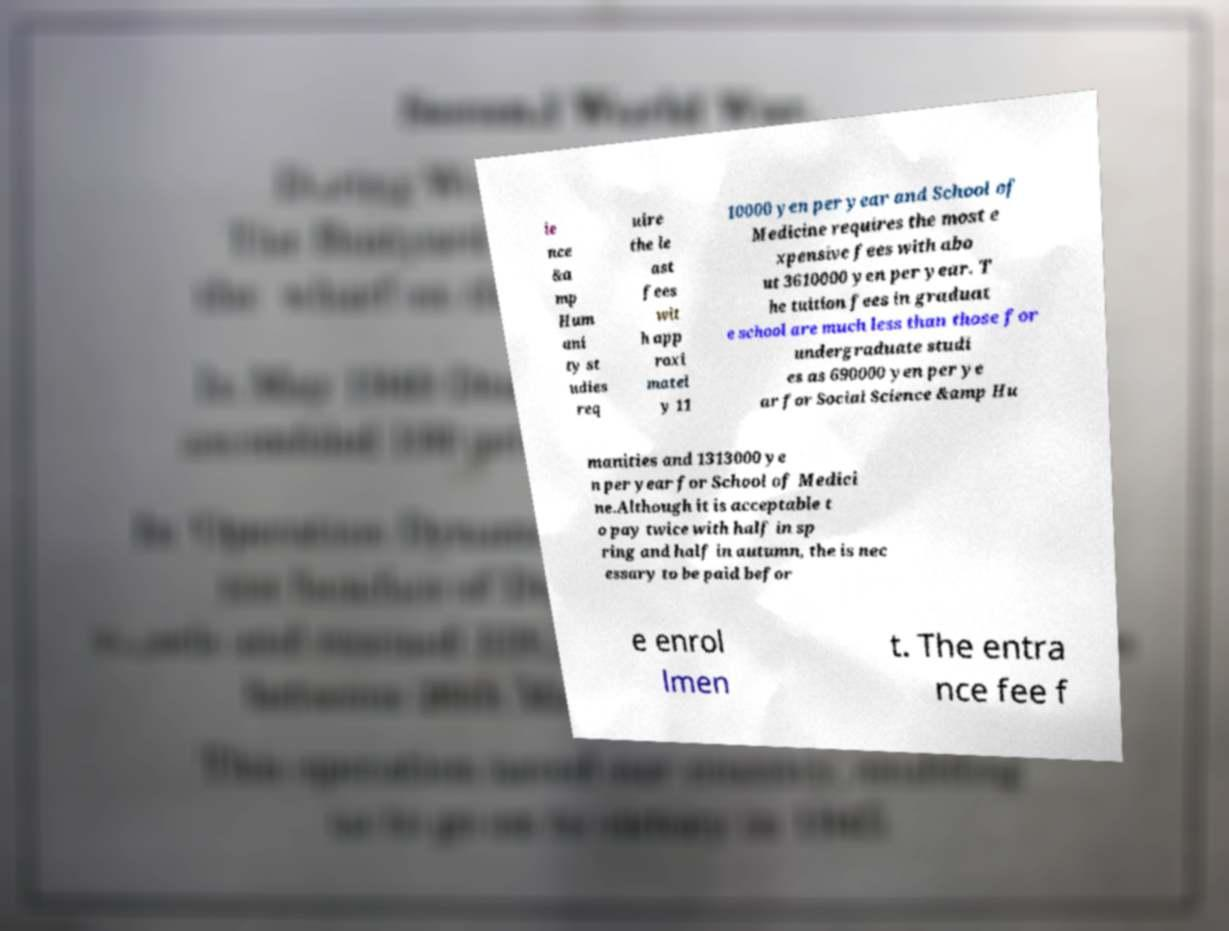Could you extract and type out the text from this image? ie nce &a mp Hum ani ty st udies req uire the le ast fees wit h app roxi matel y 11 10000 yen per year and School of Medicine requires the most e xpensive fees with abo ut 3610000 yen per year. T he tuition fees in graduat e school are much less than those for undergraduate studi es as 690000 yen per ye ar for Social Science &amp Hu manities and 1313000 ye n per year for School of Medici ne.Although it is acceptable t o pay twice with half in sp ring and half in autumn, the is nec essary to be paid befor e enrol lmen t. The entra nce fee f 